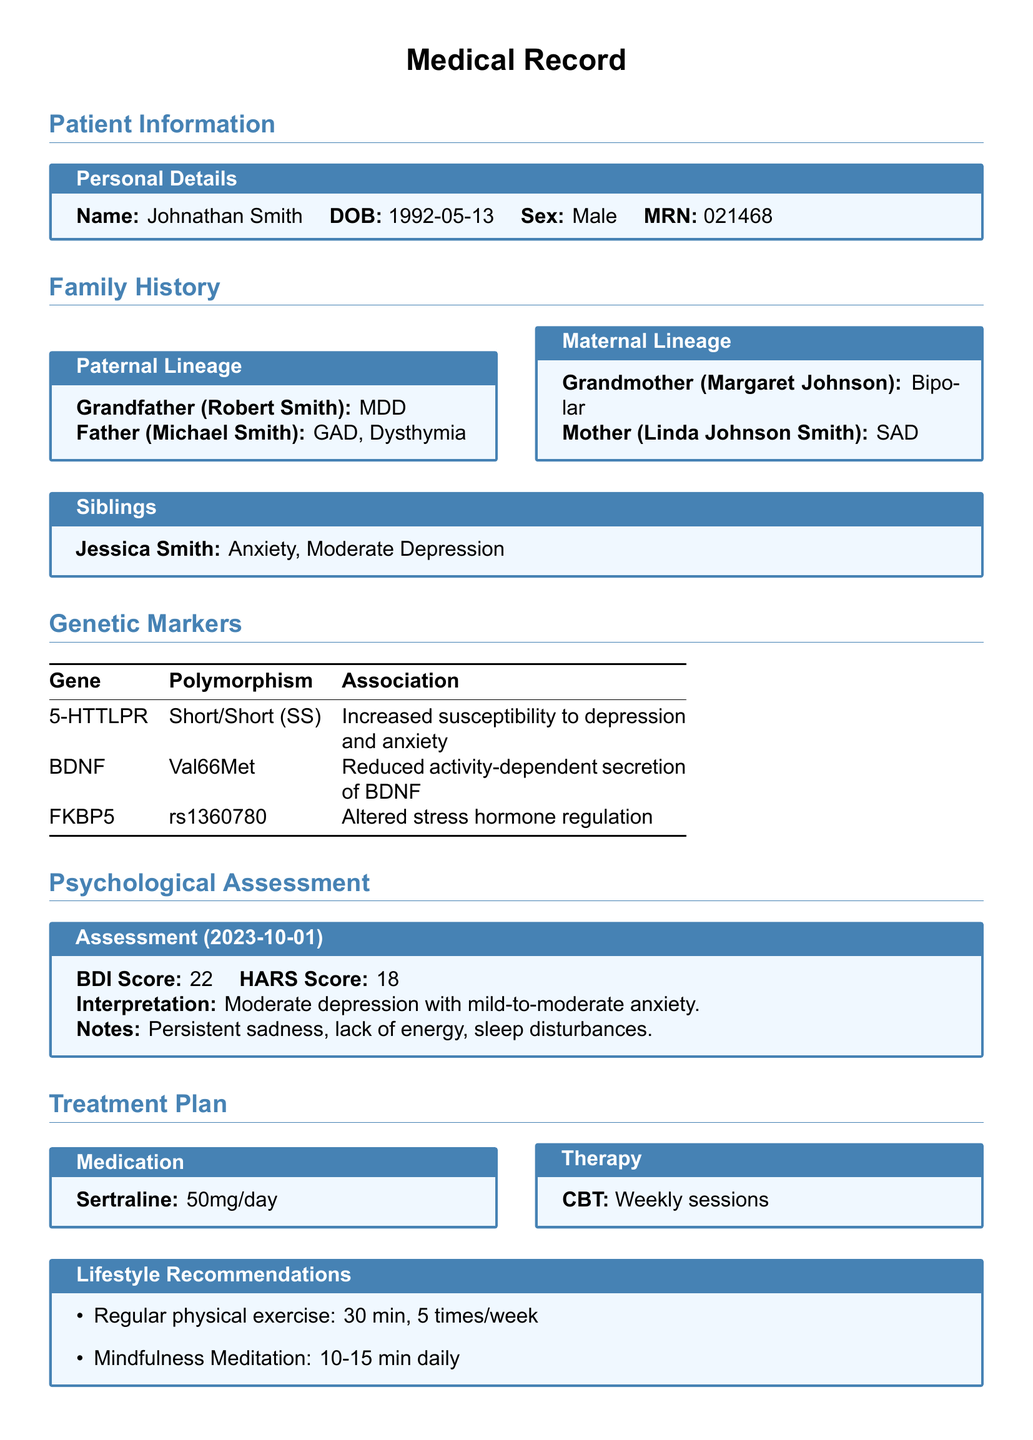What is the patient's name? The patient's name is displayed in the Personal Details section.
Answer: Johnathan Smith What is the date of birth? The date of birth is provided in the Personal Details section of the document.
Answer: 1992-05-13 What condition did Robert Smith have? Robert Smith's condition is noted in the Paternal Lineage section.
Answer: MDD What is the BDI Score? The BDI Score is recorded in the Psychological Assessment section.
Answer: 22 What medication is prescribed? The medication is listed in the Treatment Plan section.
Answer: Sertraline How often are CBT sessions? The frequency of CBT sessions is mentioned in the Therapy part of the Treatment Plan.
Answer: Weekly Which gene is associated with altered stress hormone regulation? The association is noted in the Genetic Markers section under FKBP5.
Answer: FKBP5 What is the relationship between Jessica Smith and Johnathan Smith? Jessica Smith's relationship is inferred from the Siblings section.
Answer: Sister What lifestyle recommendation includes physical exercise? The lifestyle recommendation is provided in the Lifestyle Recommendations section.
Answer: Regular physical exercise 